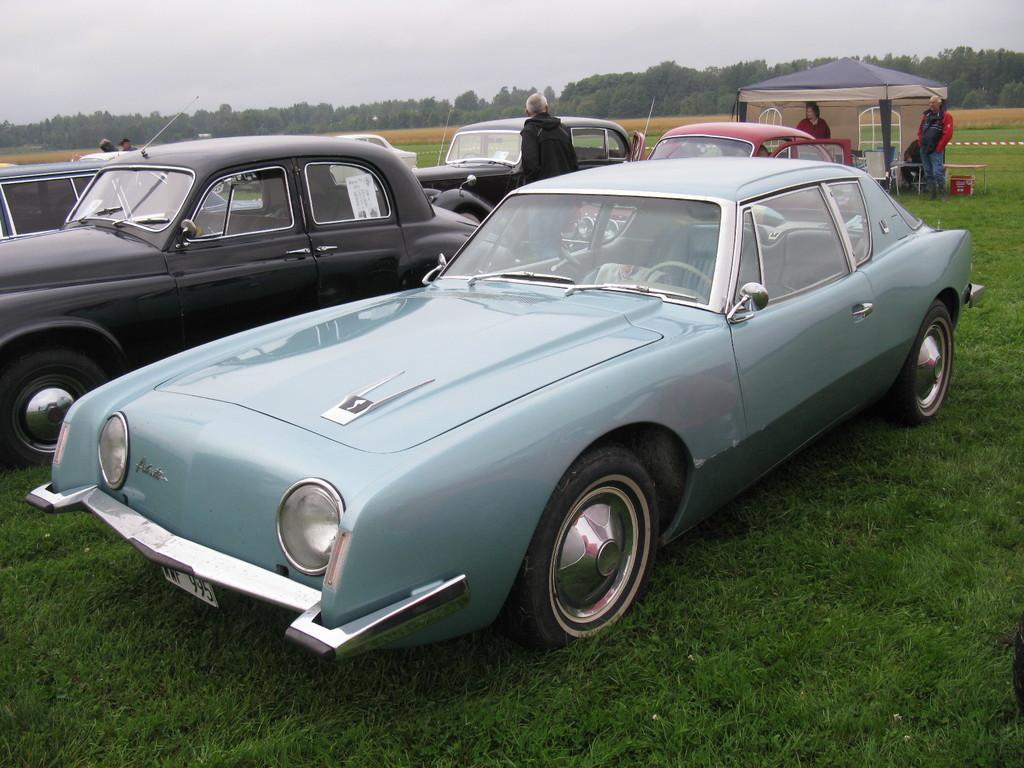Please provide a concise description of this image. In the image there are few cars on the ground. There is grass on the ground. Behind the cars there are few people standing and also there is a tent and there are few objects on the ground. In the background there are trees. At the top of the image there is a sky. 